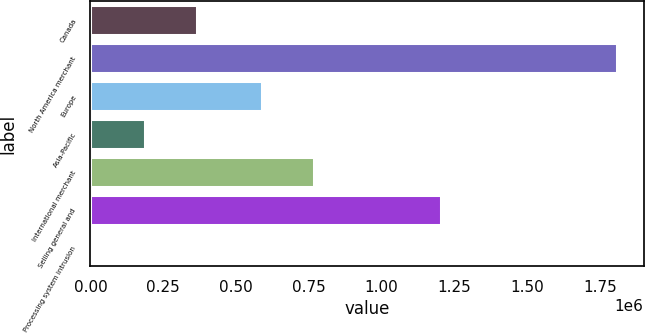Convert chart to OTSL. <chart><loc_0><loc_0><loc_500><loc_500><bar_chart><fcel>Canada<fcel>North America merchant<fcel>Europe<fcel>Asia-Pacific<fcel>International merchant<fcel>Selling general and<fcel>Processing system intrusion<nl><fcel>367398<fcel>1.80899e+06<fcel>587463<fcel>187199<fcel>767662<fcel>1.20351e+06<fcel>7000<nl></chart> 